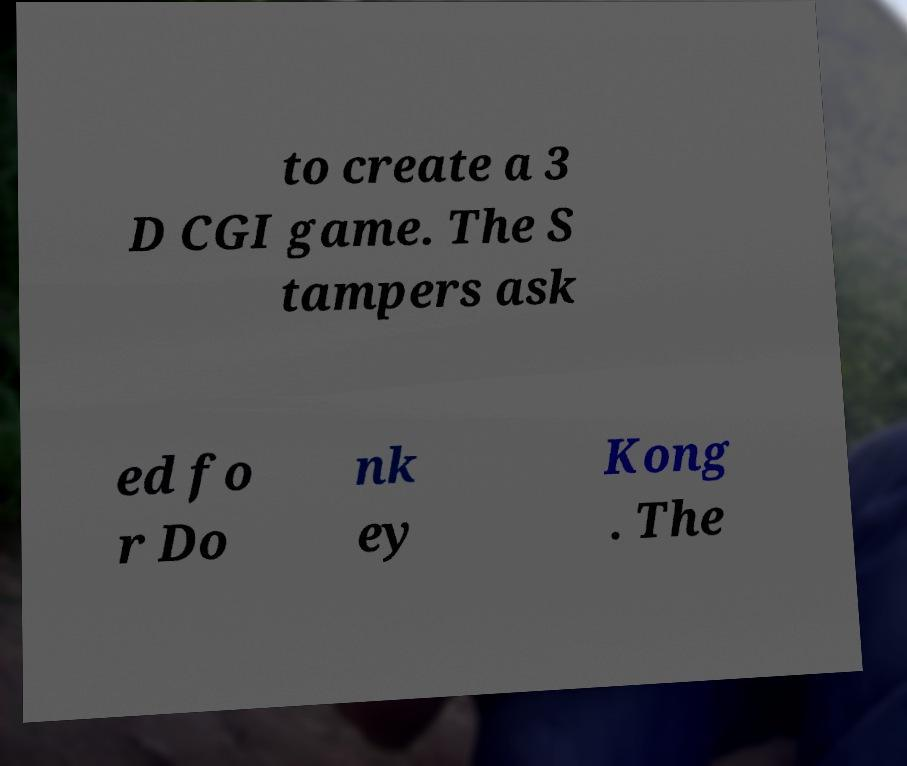Could you extract and type out the text from this image? to create a 3 D CGI game. The S tampers ask ed fo r Do nk ey Kong . The 